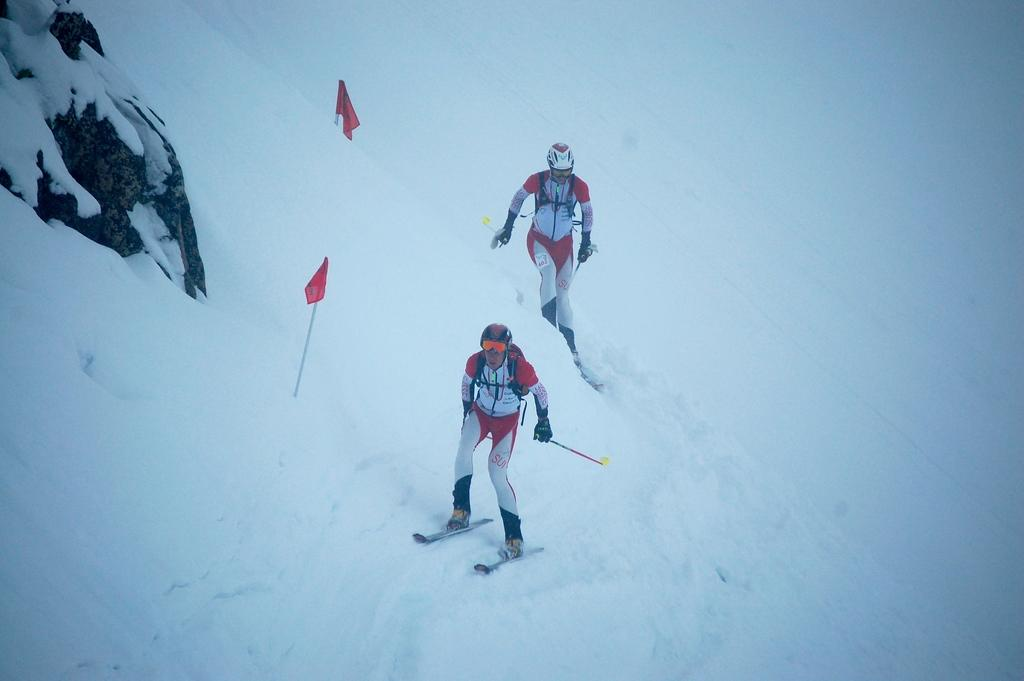How many people are in the image? There are two persons in the image. What are the persons doing in the image? The persons are skating on the snow using sky boards. What colors are the dresses of the persons? The persons are wearing white and red color dress. What are the persons holding in their hands? They are holding two sticks. What can be seen in the image related to flags? There are flags in red color in the image. What type of hole can be seen in the image? There is no hole present in the image. What sound do the bells make in the image? There are no bells present in the image. 